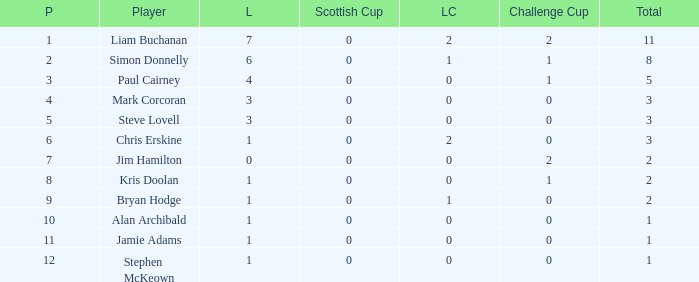How many points did player 7 score in the challenge cup? 1.0. 